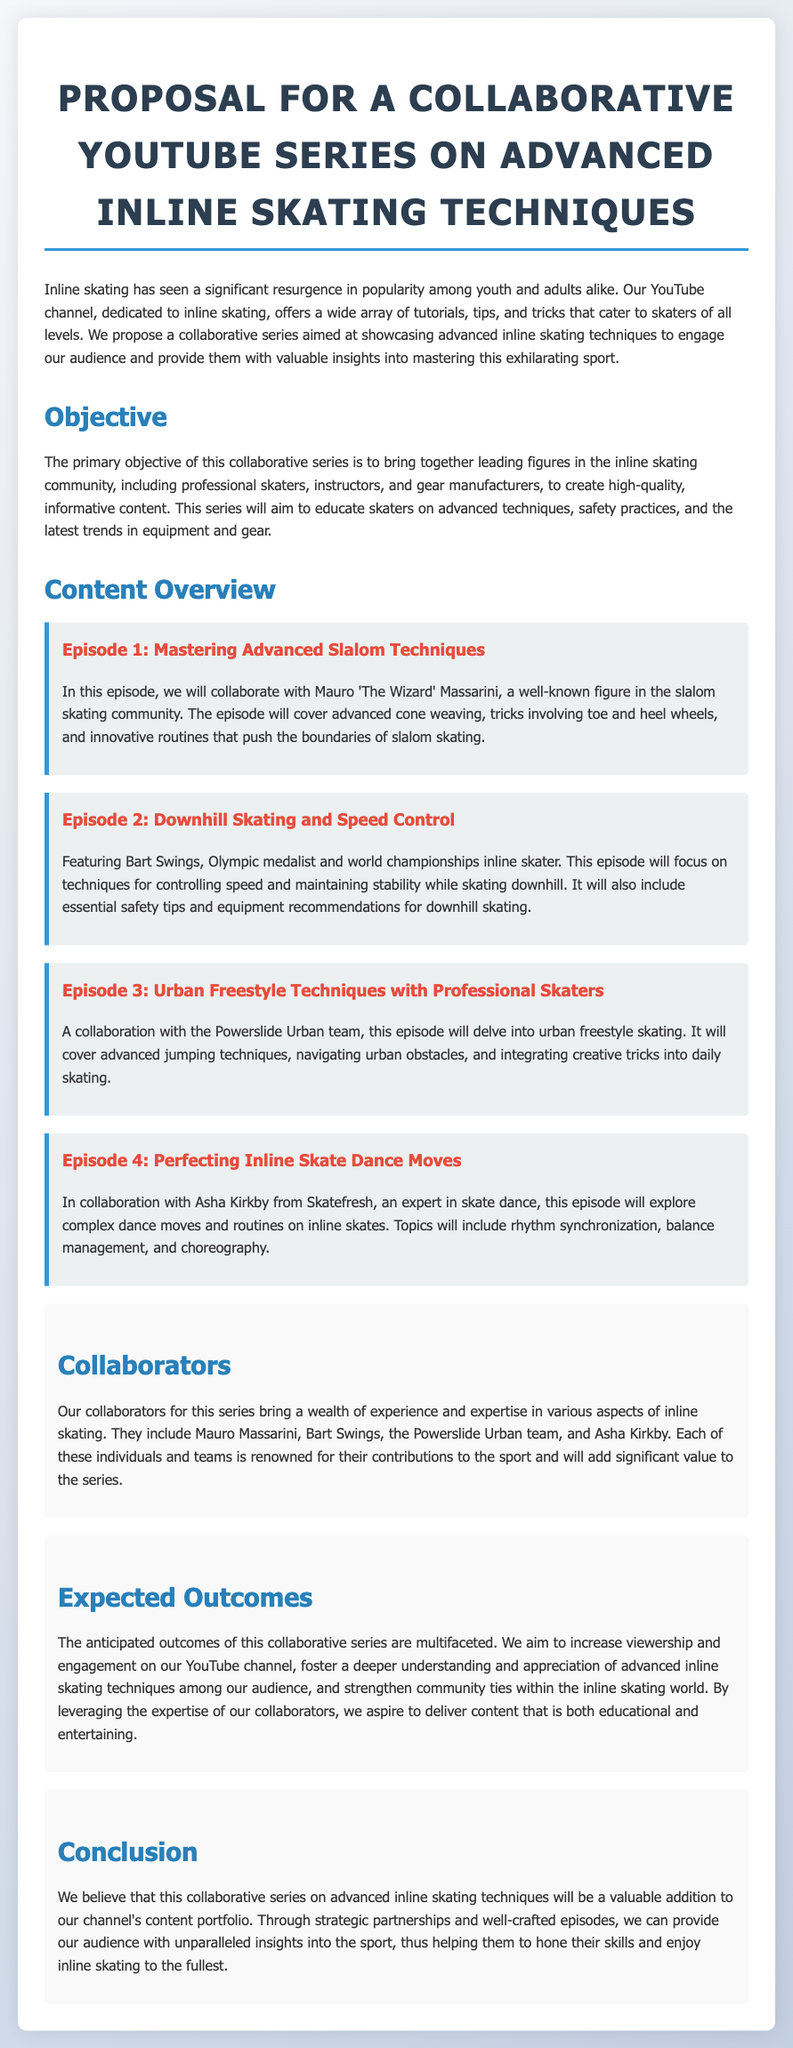What is the title of the proposal? The title of the proposal is stated at the beginning of the document, which is "Proposal for a Collaborative YouTube Series on Advanced Inline Skating Techniques."
Answer: Proposal for a Collaborative YouTube Series on Advanced Inline Skating Techniques Who is collaborating on Episode 1? Episode 1 features Mauro 'The Wizard' Massarini as the collaborator, as mentioned in the content overview section.
Answer: Mauro 'The Wizard' Massarini What is the main focus of Episode 3? Episode 3 focuses on urban freestyle skating techniques, including advanced jumping techniques and navigating urban obstacles.
Answer: Urban freestyle skating techniques How many episodes are detailed in the proposal? The proposal lists a total of four episodes in the content overview section.
Answer: Four What is the anticipated outcome regarding viewership? The anticipated outcome is to increase viewership on the YouTube channel, explicitly mentioned in the expected outcomes section.
Answer: Increase viewership What type of content does the proposal aim to showcase? The proposal aims to showcase advanced inline skating techniques, as stated in the introductory paragraph.
Answer: Advanced inline skating techniques Who is featured in Episode 2? Episode 2 features Bart Swings, as specified in the content overview.
Answer: Bart Swings What is the primary objective of the series? The primary objective is to create high-quality, informative content that educates skaters on advanced techniques and safety practices.
Answer: Educate skaters on advanced techniques and safety practices 